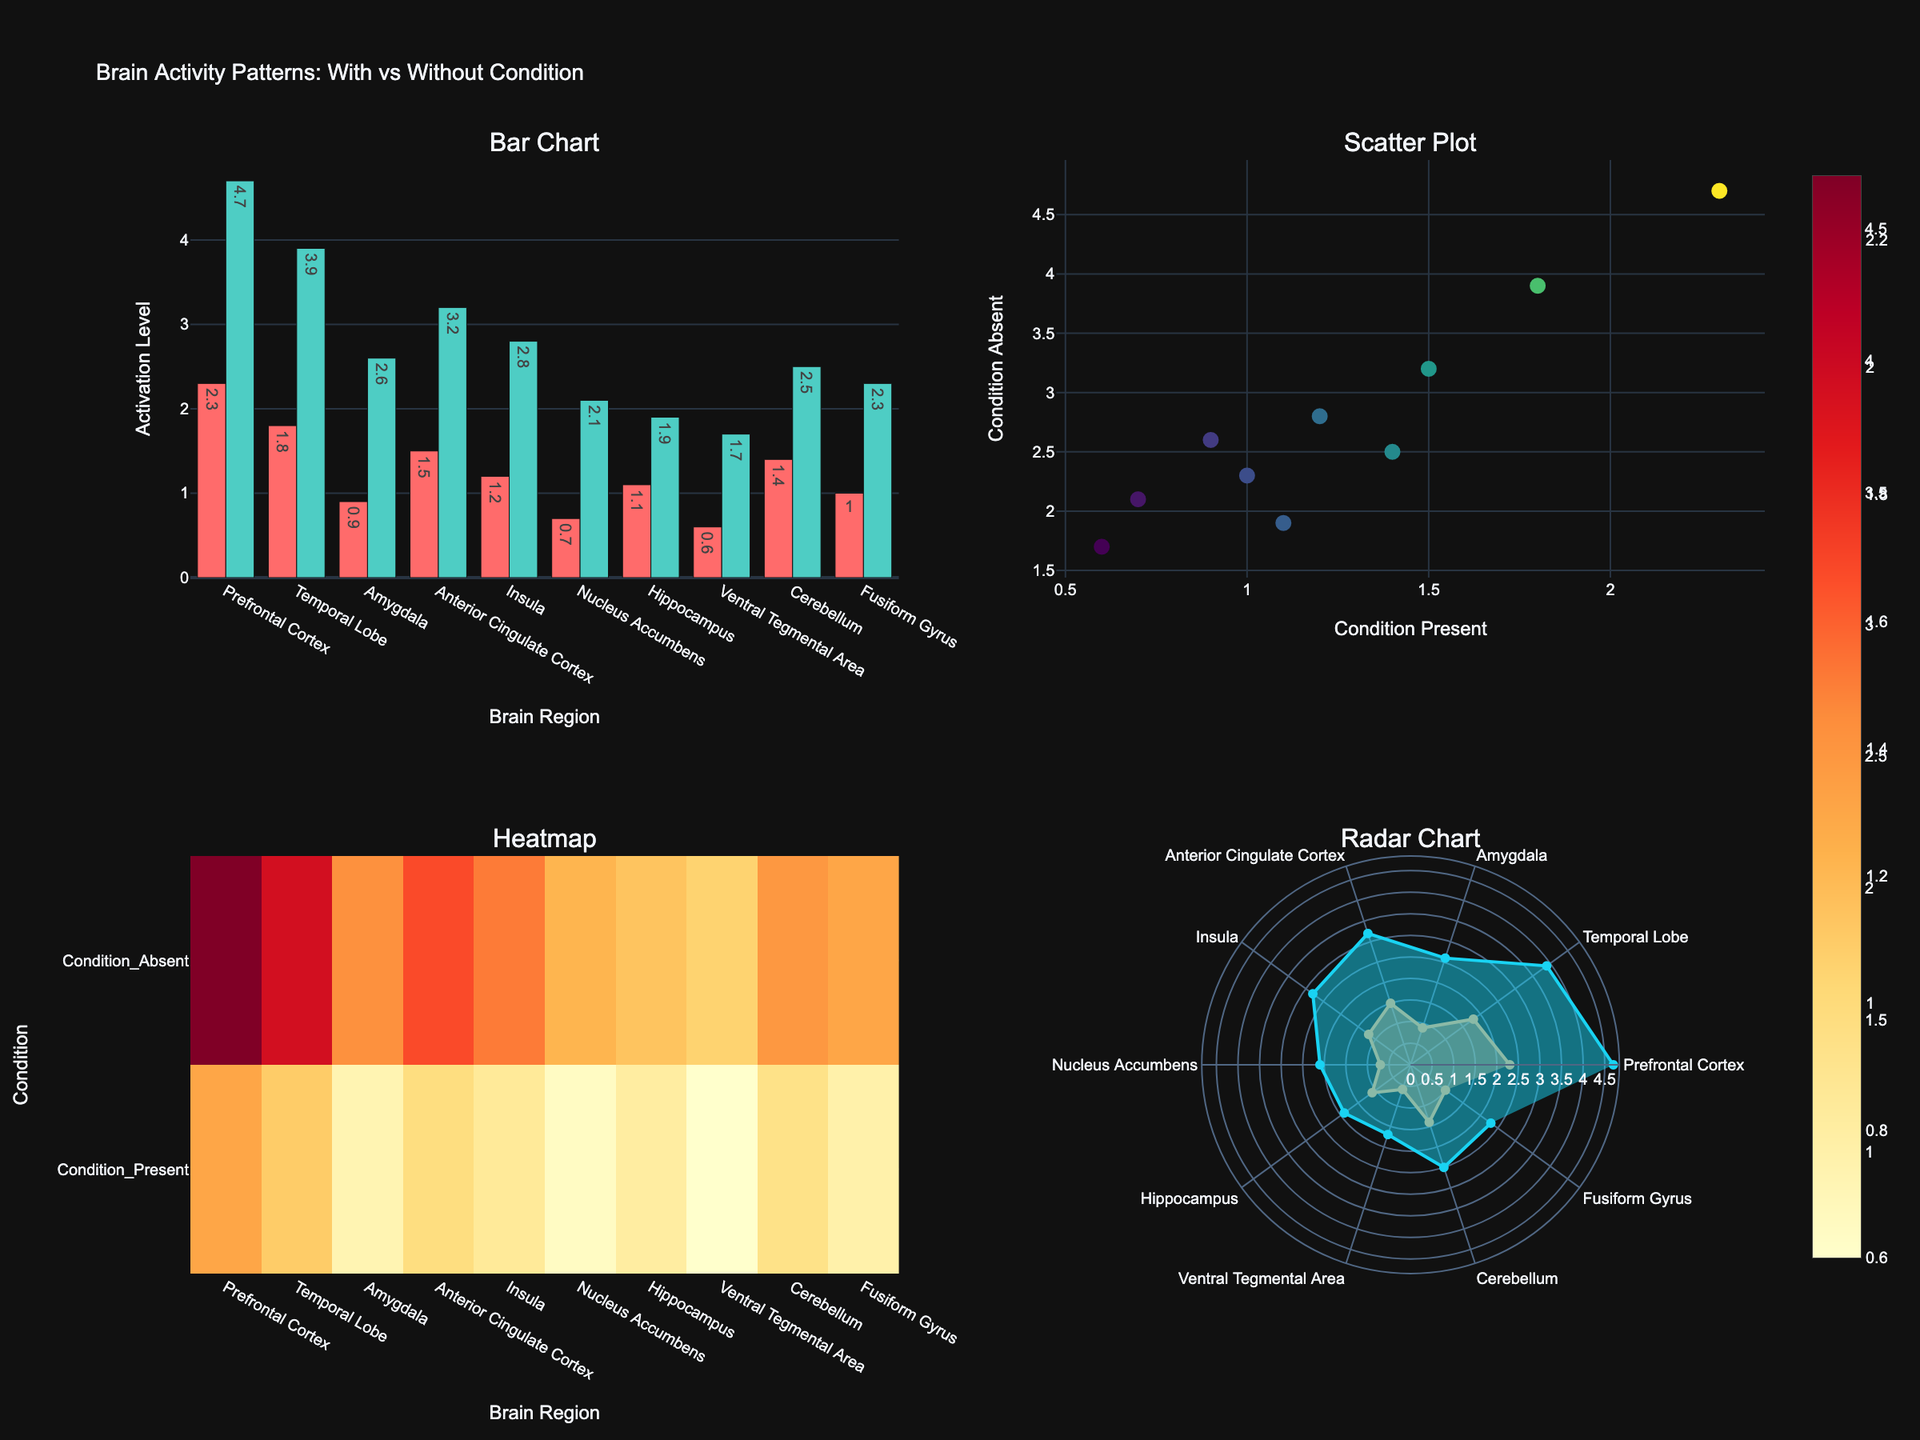What is the title of the figure? Look at the top of the figure to find the title. The title usually provides an overview of what the figure is about.
Answer: Brain Activity Patterns: With vs Without Condition How many subplots are present in the figure? The figure is divided into sections. Count each individual chart in each section to determine the total number of subplots.
Answer: 4 Which brain region shows the highest activation in the 'Condition Absent' group based on the bar chart? Look at the bar chart subplot in the top left. Compare the heights of the green bars to find the tallest one, which indicates the highest activation level. The corresponding brain region is the one labeled below this bar.
Answer: Prefrontal Cortex What is the activation level of the Amygdala for individuals with the condition? Refer to the bar chart (top-left subplot). Identify the bar representing the Amygdala and look at the corresponding value of the red bar, which indicates the activation level for individuals with the condition.
Answer: 0.9 Which brain region has the smallest difference in activation levels between 'Condition Present' and 'Condition Absent'? You need to check the bar chart and calculate the differences between pairs of bars for each brain region. Find the region with the smallest difference by subtracting the 'Condition Present' value from the 'Condition Absent' value and comparing all results.
Answer: Hippocampus For the scatter plot, which brain regions correspond to the highest and lowest activation levels in 'Condition Present' and 'Condition Absent' respectively? Examine the scattered points in the top-right subplot, look for the point with the highest x (Condition Present) and the one with the lowest y (Condition Absent). Hover or refer to point annotations to find the corresponding brain regions.
Answer: Prefrontal Cortex, Ventral Tegmental Area What is the maximum activation level observed in the heatmap? Check the heatmap subplot in the bottom-left. Look for the cell with the highest color intensity, which represents the maximum activation level.
Answer: 4.7 Which brain region exhibits the highest difference in activation between the two conditions as seen in the radar chart? Look at the radar chart at the bottom-right and observe the radial lines. Comparing the lengths of the two sets of lines, identify the brain region with the most considerable divergence between the 'Condition Present' and 'Condition Absent' lines.
Answer: Prefrontal Cortex What pattern can be observed from the scatter plot regarding the relationship between 'Condition Present' and 'Condition Absent' activation levels? Observing the scatter plot at the top-right, note the clustering and diagonal trend of the points, which indicates a pattern of general correspondence but with slightly lower values for Condition Present.
Answer: 'Condition Absent' generally has higher activation levels Approximately what percentage of the brain regions have an activation level above 1 for individuals with the condition? From the bar chart and radar chart, count the number of red bars (or points) above the 1.0 mark, then divide this by the total number of brain regions (10) and multiply by 100 to get the percentage.
Answer: 70% 